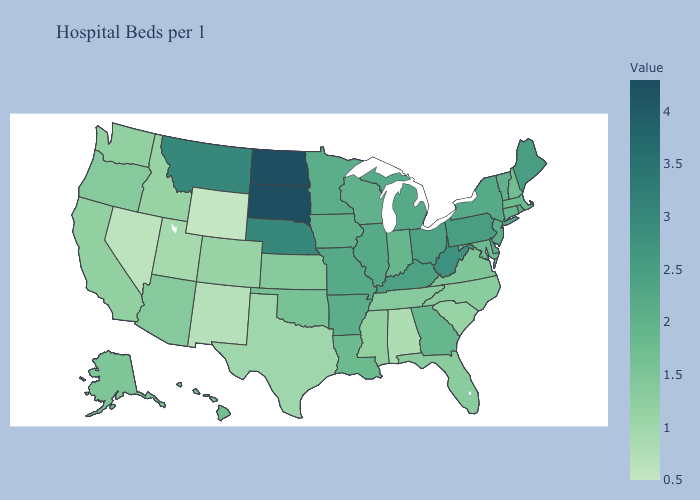Which states have the lowest value in the Northeast?
Keep it brief. New Hampshire. Does Wisconsin have the lowest value in the MidWest?
Keep it brief. No. Does Delaware have a lower value than Kansas?
Be succinct. No. Which states have the highest value in the USA?
Keep it brief. North Dakota, South Dakota. Which states hav the highest value in the MidWest?
Write a very short answer. North Dakota, South Dakota. 